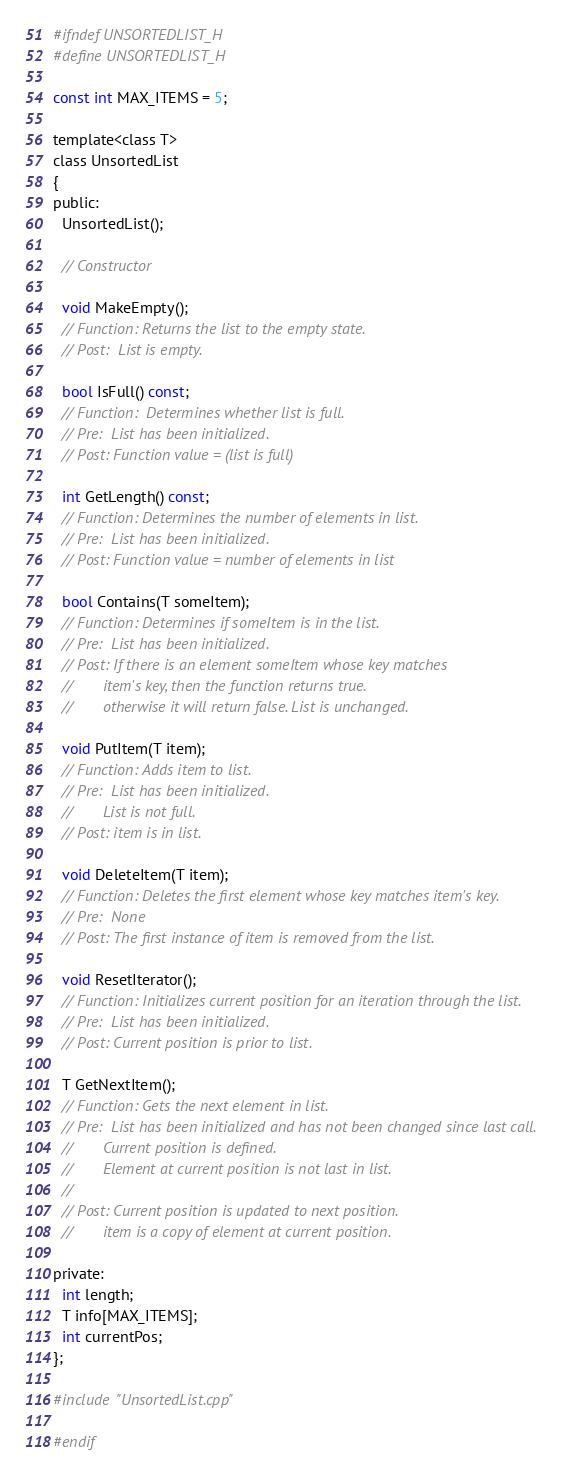<code> <loc_0><loc_0><loc_500><loc_500><_C_>#ifndef UNSORTEDLIST_H
#define UNSORTEDLIST_H

const int MAX_ITEMS = 5;

template<class T>
class UnsortedList
{
public:
  UnsortedList();

  // Constructor
  
  void MakeEmpty();
  // Function: Returns the list to the empty state.
  // Post:  List is empty.
  
  bool IsFull() const;
  // Function:  Determines whether list is full.
  // Pre:  List has been initialized.
  // Post: Function value = (list is full)

  int GetLength() const;
  // Function: Determines the number of elements in list.
  // Pre:  List has been initialized.
  // Post: Function value = number of elements in list

  bool Contains(T someItem);
  // Function: Determines if someItem is in the list.
  // Pre:  List has been initialized.
  // Post: If there is an element someItem whose key matches
  //       item's key, then the function returns true.
  // 	     otherwise it will return false. List is unchanged.

  void PutItem(T item);
  // Function: Adds item to list.
  // Pre:  List has been initialized.
  //       List is not full.
  // Post: item is in list.

  void DeleteItem(T item);
  // Function: Deletes the first element whose key matches item's key.
  // Pre:  None
  // Post: The first instance of item is removed from the list.

  void ResetIterator();
  // Function: Initializes current position for an iteration through the list.
  // Pre:  List has been initialized.
  // Post: Current position is prior to list.

  T GetNextItem();
  // Function: Gets the next element in list.
  // Pre:  List has been initialized and has not been changed since last call.
  //       Current position is defined.
  //       Element at current position is not last in list.
  //	     
  // Post: Current position is updated to next position.
  //       item is a copy of element at current position.

private:
  int length;
  T info[MAX_ITEMS];
  int currentPos;
};

#include "UnsortedList.cpp"

#endif
</code> 